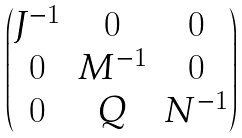<formula> <loc_0><loc_0><loc_500><loc_500>\begin{pmatrix} J ^ { - 1 } & 0 & 0 \\ 0 & M ^ { - 1 } & 0 \\ 0 & Q & N ^ { - 1 } \\ \end{pmatrix}</formula> 